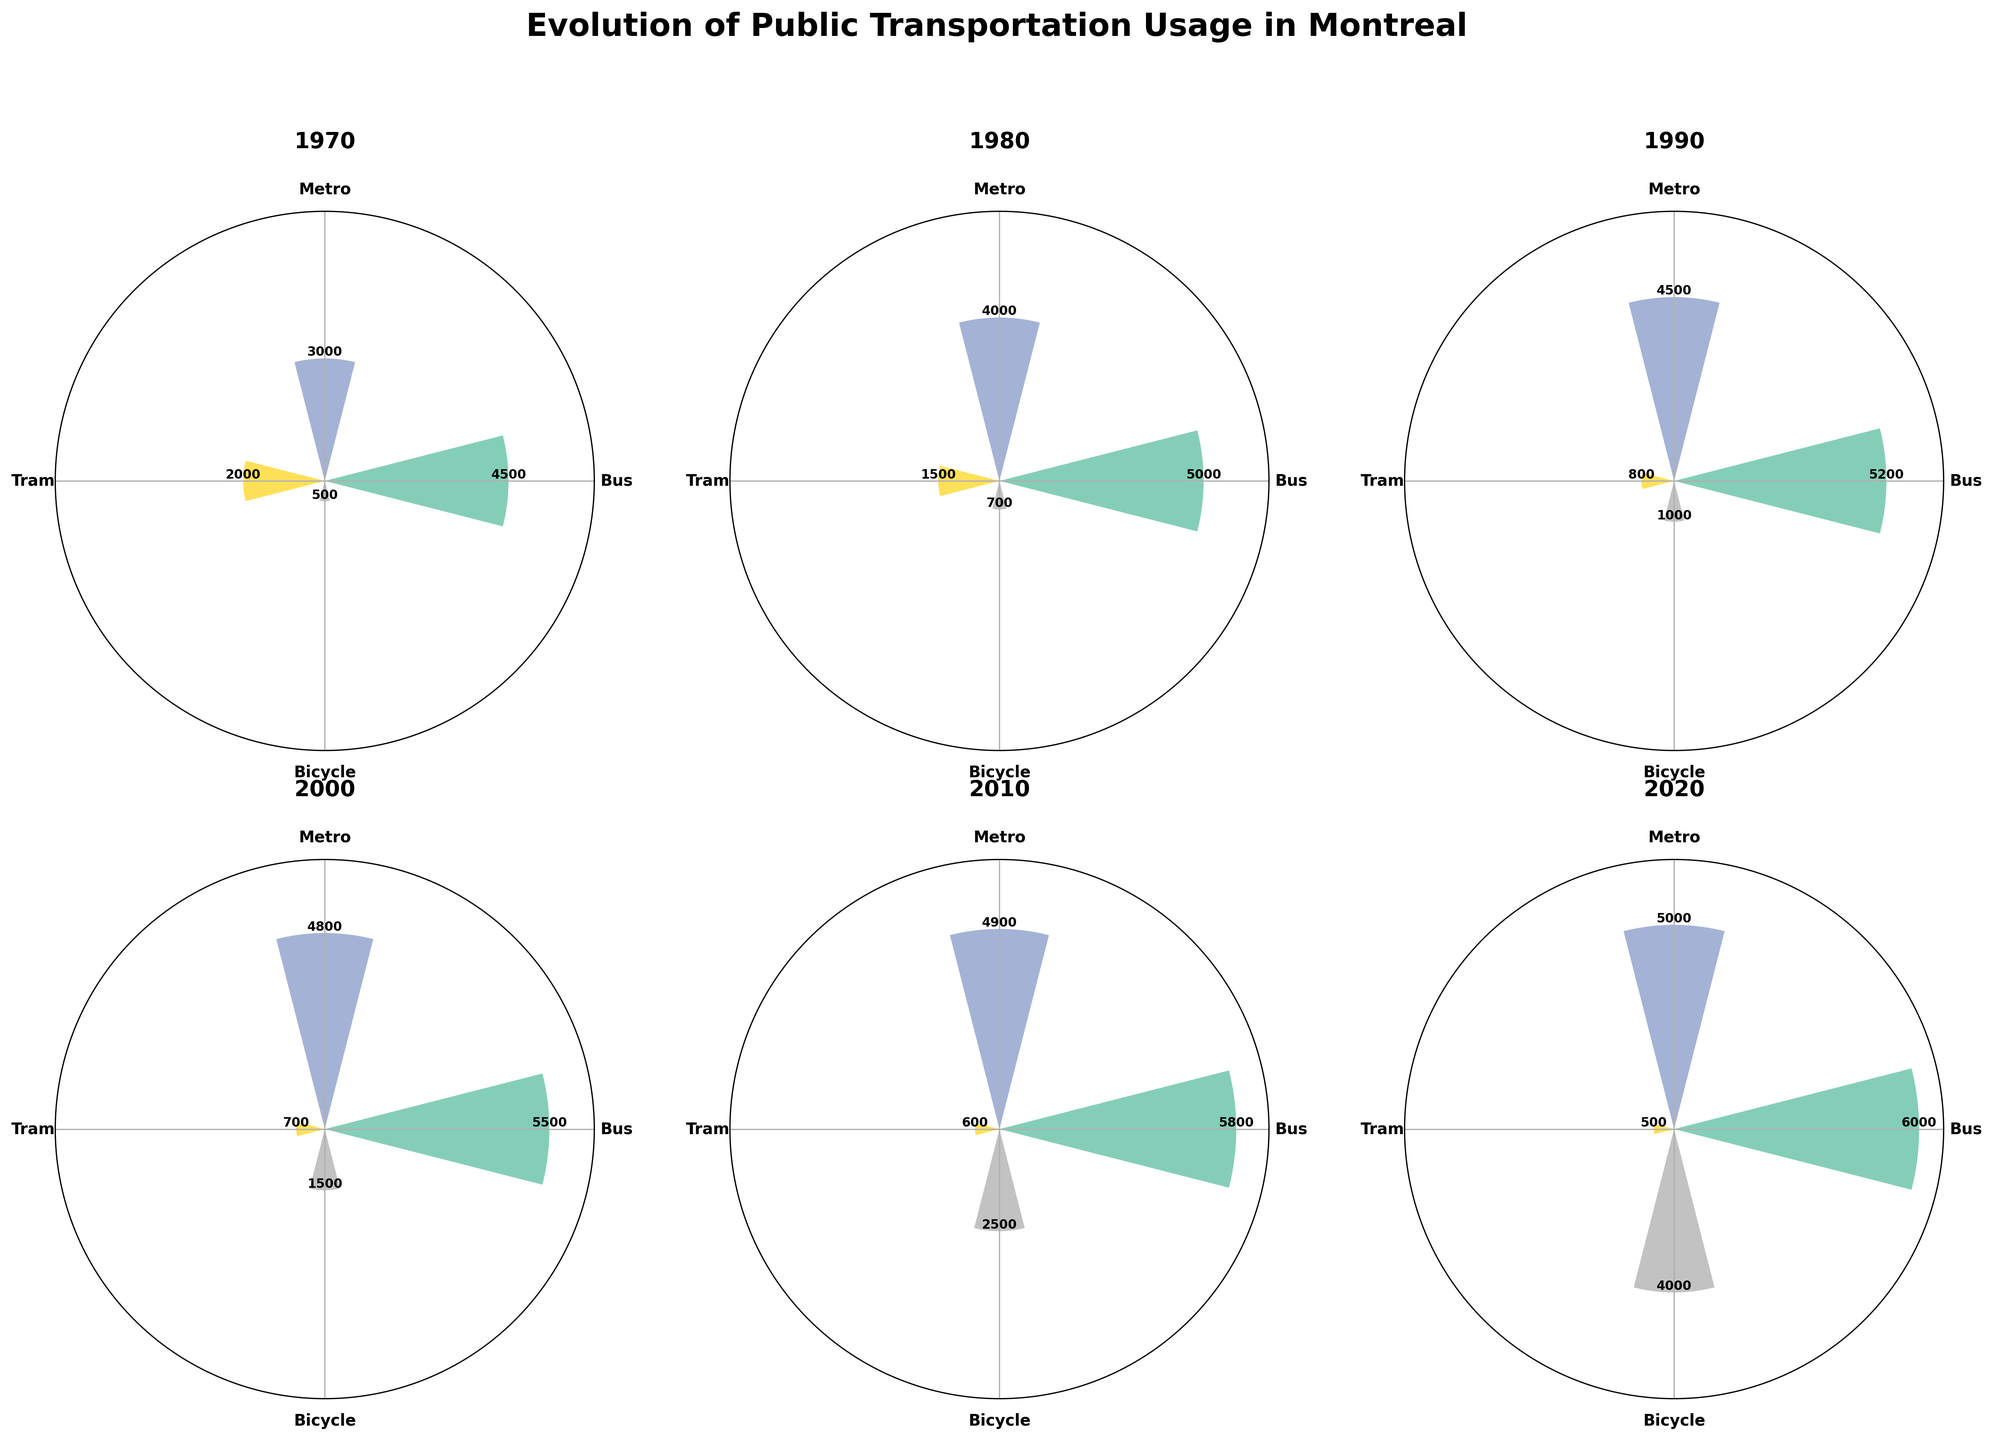What year has the highest usage of bicycles? Looking at the rose charts, the usage of bicycles appears highest in the year 2020, where the radii of bicycle usage are the highest.
Answer: 2020 Which transport mode consistently shows an increase in usage hours over the decades? By examining the rose charts from 1970 to 2020, the bus usage hours consistently increase in height over each decade.
Answer: Bus How does the metro usage in 2000 compare to that in 2010? Metro usage in 2000 has a slightly smaller radius compared to 2010. The 2000 bar is shorter than the 2010's in the rose chart for metro.
Answer: 2010 What's the difference in tram usage hours between 1970 and 2020? From the chart, tram usage in 1970 is 2000 hours, and in 2020 it's 500 hours. The difference is 2000 - 500.
Answer: 1500 hours What is the trend in bicycle usage from 1970 to 2020? By examining the increasing radii of the bicycle segments through the decades, we notice a clear increasing trend in bicycle usage.
Answer: Increasing Which year shows the most diverse usage among the four transport modes? Look for the year where the segments' height difference is the smallest among transport modes. 2020 is the year where usage is relatively balanced among modes.
Answer: 2020 Is there a decade where tram usage drops significantly? Observing the heights of the tram segments, there is a notable drop from 1980 (1500 hours) to 1990 (800 hours).
Answer: 1990 What can you infer about public transportation preferences over the years? Analyzing the whole chart, bus and metro usage increases, but tram usage decreases significantly, while bicycle usage significantly increases, especially in recent decades.
Answer: Increased bus and metro usage, decreased tram usage, and significantly increased bicycle usage 